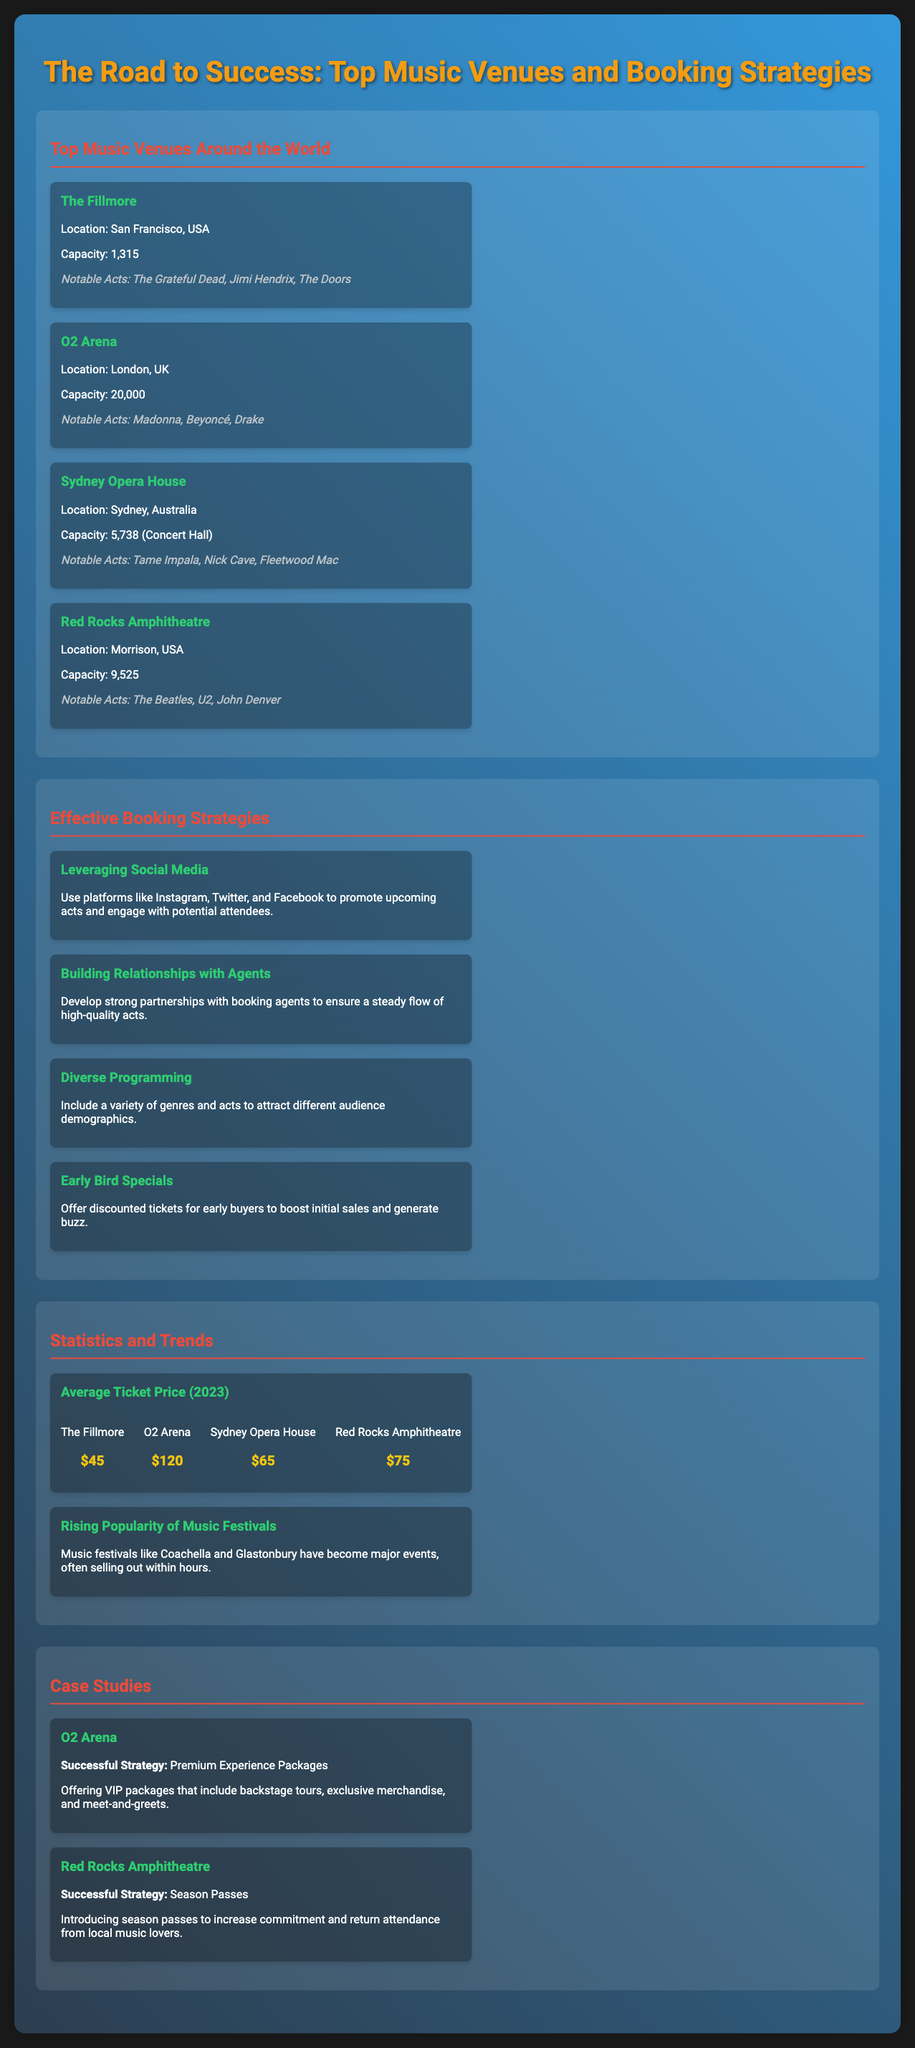What is the capacity of the O2 Arena? The O2 Arena has a capacity of 20,000.
Answer: 20,000 Who are some notable acts that performed at The Fillmore? Notable acts at The Fillmore include The Grateful Dead, Jimi Hendrix, and The Doors.
Answer: The Grateful Dead, Jimi Hendrix, The Doors What is one effective booking strategy mentioned? One effective booking strategy is Building Relationships with Agents.
Answer: Building Relationships with Agents What is the average ticket price at Sydney Opera House? The average ticket price at Sydney Opera House is $65.
Answer: $65 What successful strategy is used by the O2 Arena? The O2 Arena's successful strategy includes Premium Experience Packages.
Answer: Premium Experience Packages Which venue has hosted the most notable acts mentioned? Red Rocks Amphitheatre has hosted notable acts such as The Beatles, U2, and John Denver.
Answer: Red Rocks Amphitheatre What are early bird specials aimed at? Early bird specials are aimed at boosting initial sales and generating buzz.
Answer: Boosting initial sales and generating buzz How many notable acts are listed for Red Rocks Amphitheatre? There are three notable acts listed for Red Rocks Amphitheatre.
Answer: Three 